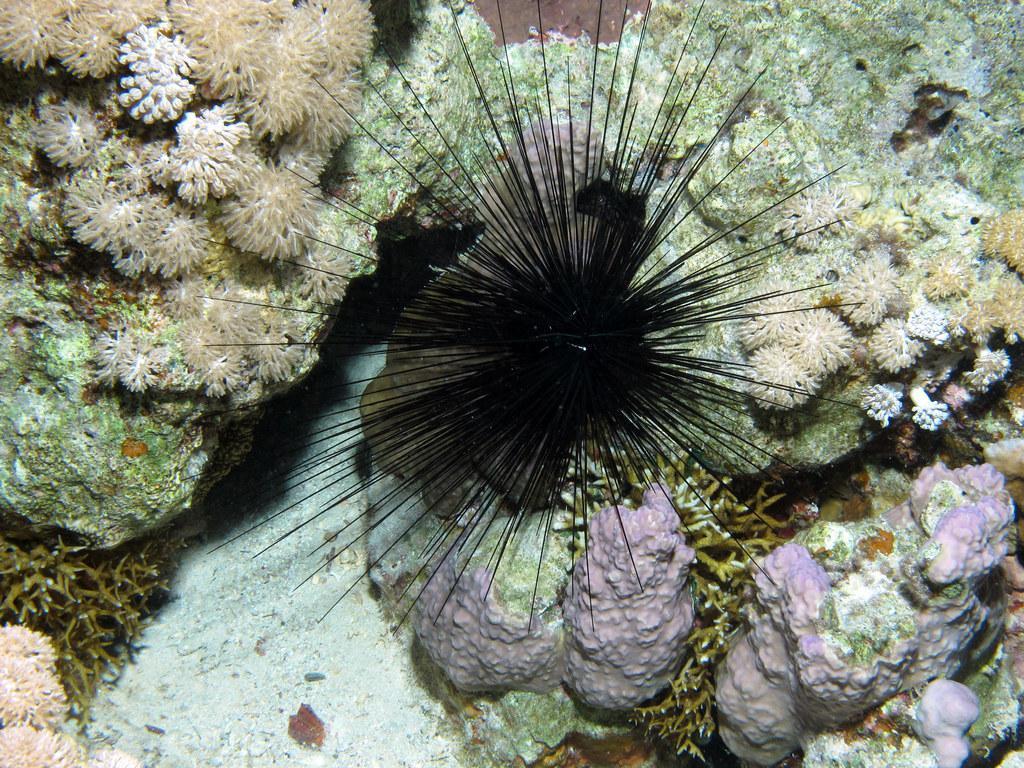Please provide a concise description of this image. This image consists of marine species. 